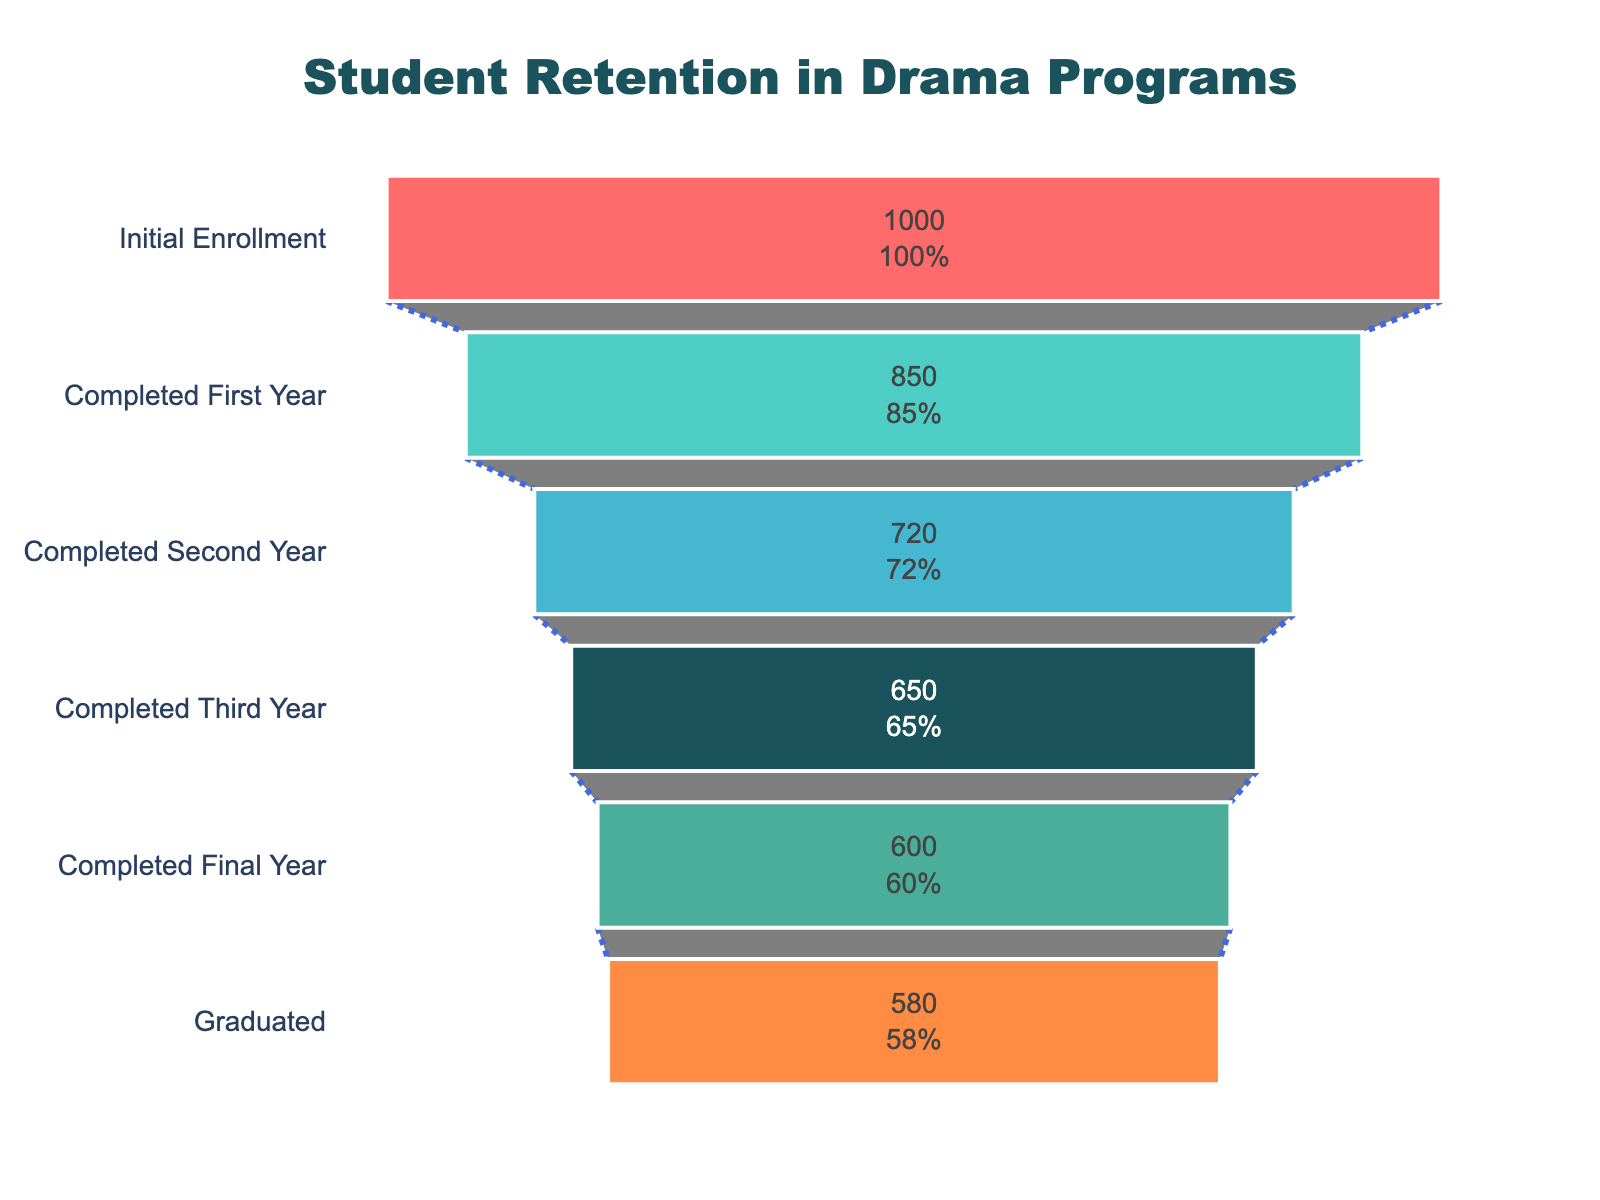How many students enrolled initially? Refer to the first stage in the figure labeled "Initial Enrollment" to find the student count.
Answer: 1000 What's the percentage of students who graduated relative to those who initially enrolled? Divide the number of students who graduated (580) by the initial enrollment (1000), then multiply by 100 to get the percentage: (580 / 1000) * 100
Answer: 58% What's the difference in student numbers between the second and third years? Subtract the number of students in the third year (650) from those in the second year (720): 720 - 650
Answer: 70 What is the retention rate from the first year to the second year? Divide the number of students completing the second year (720) by those who completed the first year (850), then multiply by 100 to get the percentage: (720 / 850) * 100
Answer: 84.71% Compare the number of students after the third year and those who graduated. Compare the number of students completing the third year (650) with those who graduated (580). The number after the third year is greater.
Answer: Third year > Graduated What does the shape of the funnel chart imply about student retention over the years? The funnel narrows as it goes down, indicating a decrease in the number of students progressing each year, reflective of student attrition.
Answer: Student drop-out Identify the stage with the largest decrease in student numbers. Calculate the difference between consecutive stages. The largest decrease is between the initial enrollment (1000) and completion of the first year (850): 1000 - 850
Answer: Initial Enrollment to First Year How many students were lost between the initial enrollment and graduation? Subtract the number of students who graduated (580) from those who initially enrolled (1000): 1000 - 580
Answer: 420 What percentage of students did not continue after the first year? Subtract the number of students who completed the first year (850) from the initial enrollment (1000), divide by the initial enrollment, and multiply by 100: ((1000 - 850) / 1000) * 100
Answer: 15% Which color represents the stage with the completed second year? Identify the color associated with the "Completed Second Year" stage in the figure.
Answer: Blue 